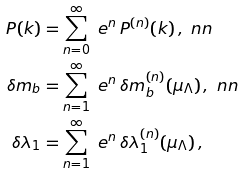Convert formula to latex. <formula><loc_0><loc_0><loc_500><loc_500>P ( k ) & = \sum _ { n = 0 } ^ { \infty } \ e ^ { n } \, P ^ { ( n ) } ( k ) \, , \ n n \\ \delta m _ { b } & = \sum _ { n = 1 } ^ { \infty } \ e ^ { n } \, \delta m _ { b } ^ { ( n ) } ( \mu _ { \Lambda } ) \, , \ n n \\ \delta \lambda _ { 1 } & = \sum _ { n = 1 } ^ { \infty } \ e ^ { n } \, \delta \lambda _ { 1 } ^ { ( n ) } ( \mu _ { \Lambda } ) \, ,</formula> 